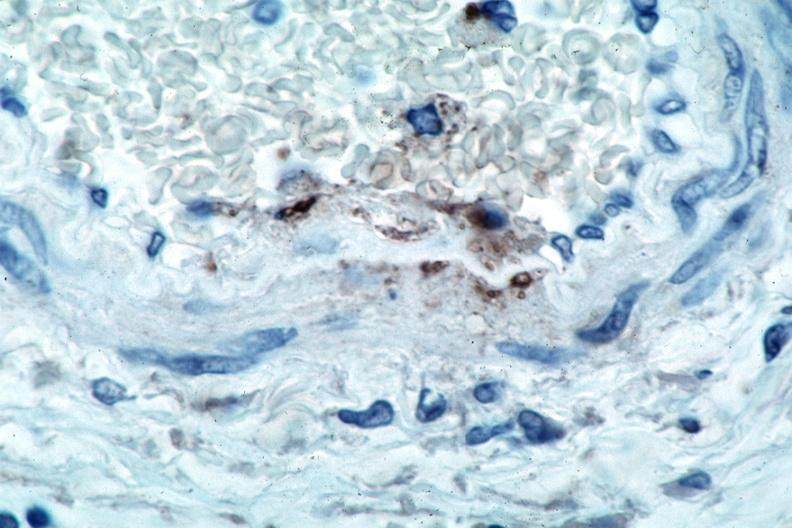what spotted fever , immunoperoxidase staining vessels for rickettsia rickettsii?
Answer the question using a single word or phrase. Vasculitis rocky mountain 